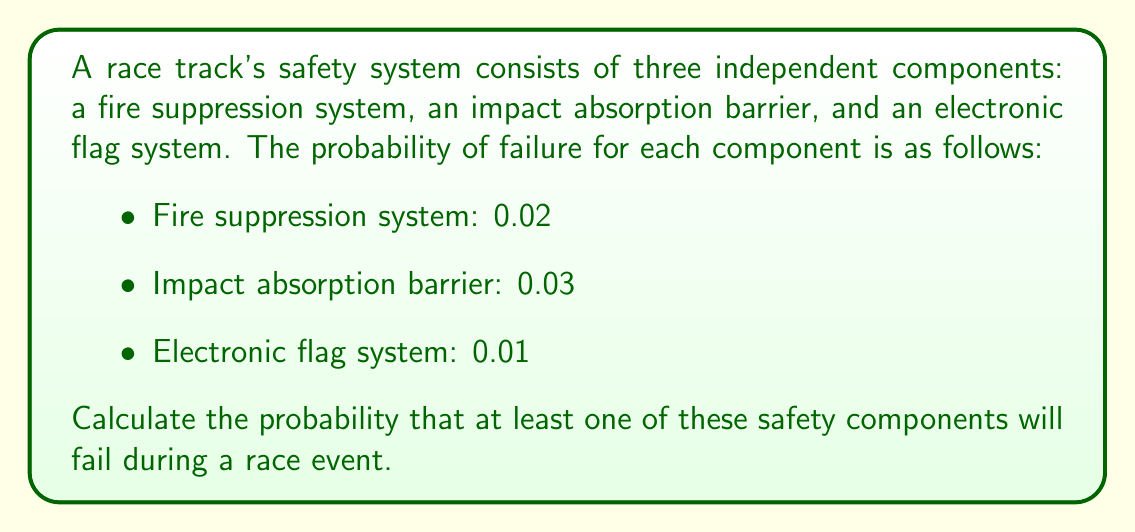What is the answer to this math problem? To solve this problem, we'll use the concept of probability of compound events and the complement rule.

1. First, let's define the events:
   $F$: Fire suppression system fails
   $I$: Impact absorption barrier fails
   $E$: Electronic flag system fails

2. We need to find $P(\text{at least one fails})$, which is equivalent to $1 - P(\text{none fail})$

3. Given:
   $P(F) = 0.02$
   $P(I) = 0.03$
   $P(E) = 0.01$

4. Since the components are independent, the probability that none fail is the product of the probabilities that each component doesn't fail:

   $P(\text{none fail}) = P(\text{not }F) \times P(\text{not }I) \times P(\text{not }E)$

5. We can calculate the probability of each component not failing:
   $P(\text{not }F) = 1 - P(F) = 1 - 0.02 = 0.98$
   $P(\text{not }I) = 1 - P(I) = 1 - 0.03 = 0.97$
   $P(\text{not }E) = 1 - P(E) = 1 - 0.01 = 0.99$

6. Now we can calculate the probability that none fail:
   $P(\text{none fail}) = 0.98 \times 0.97 \times 0.99 = 0.941094$

7. Finally, we can calculate the probability that at least one fails:
   $P(\text{at least one fails}) = 1 - P(\text{none fail}) = 1 - 0.941094 = 0.058906$

Therefore, the probability that at least one of these safety components will fail during a race event is approximately 0.058906 or 5.8906%.
Answer: $0.058906$ or $5.8906\%$ 